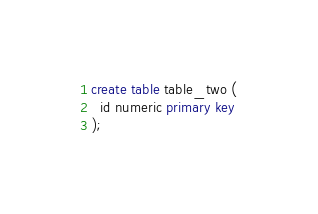Convert code to text. <code><loc_0><loc_0><loc_500><loc_500><_SQL_>create table table_two (
  id numeric primary key
);
</code> 